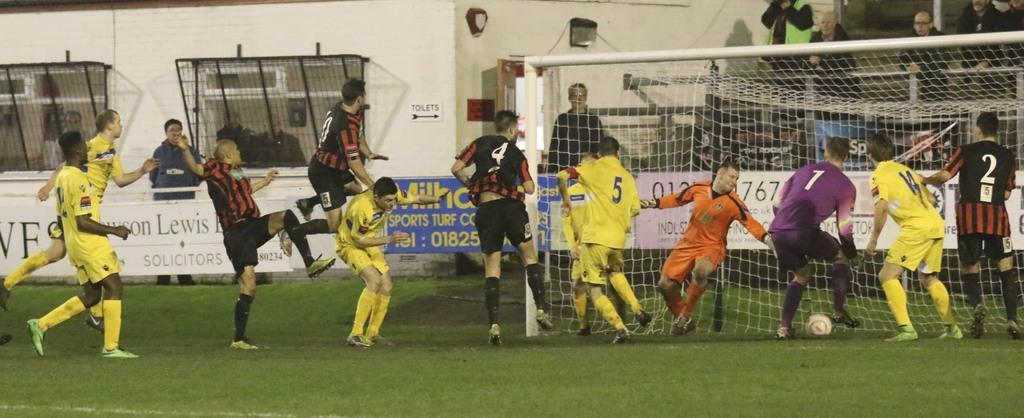<image>
Write a terse but informative summary of the picture. A group of soccer players with one team in yellow an the other in red and black with a member wearing a yellow jersey with a 5 